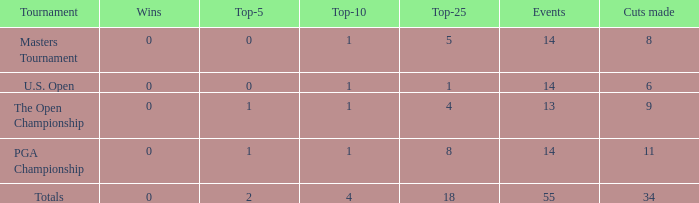What is the average top-10 when the cuts made is less than 9 and the events is more than 14? None. 